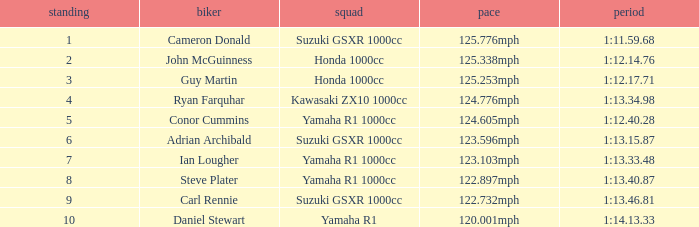What is the rank for the team with a Time of 1:12.40.28? 5.0. 